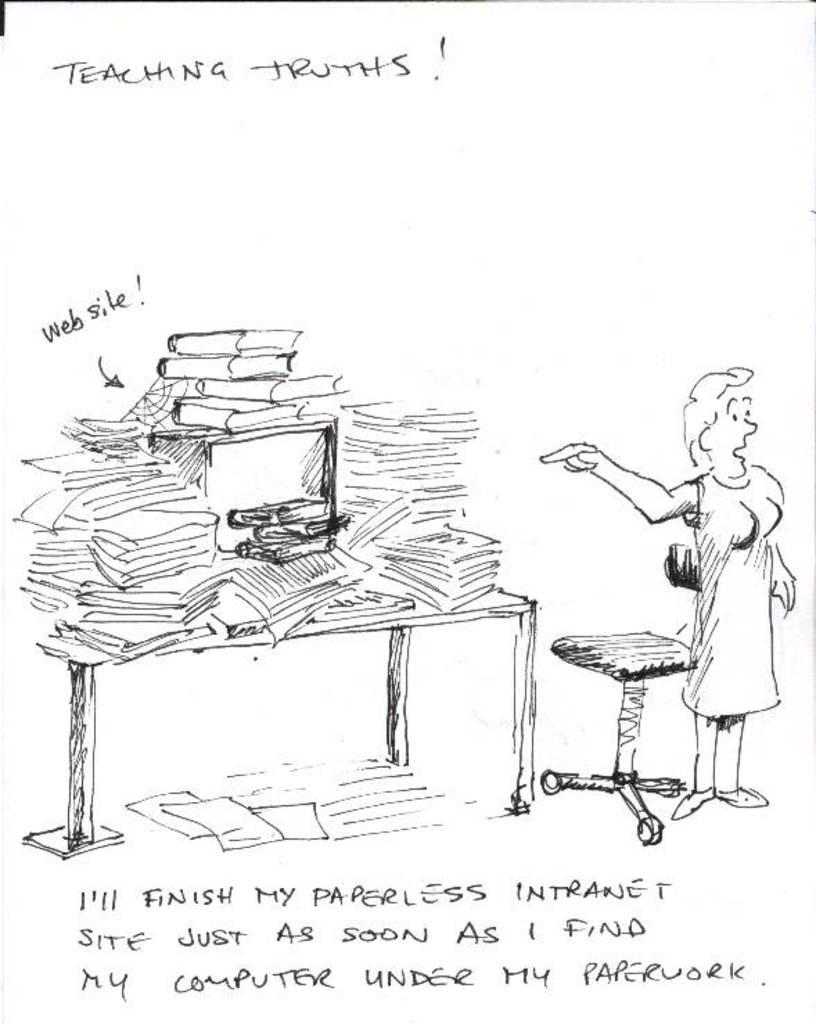What type of image is being described? The image appears to be an art piece. What furniture is visible in the image? There is a table and a stool in the image. What electronic device is present in the image? A computer is present in the image. What items related to reading and writing can be seen in the image? There are papers and books in the image. Is there a person in the image? Yes, there is a person in the image. Is there any text accompanying the art piece? Yes, there is text written under the art. What type of crime is being committed in the image? There is no crime being committed in the image; it is an art piece featuring a person, a table, a computer, papers, books, a stool, and text under the art. What type of cork is visible in the image? There is no cork present in the image. 